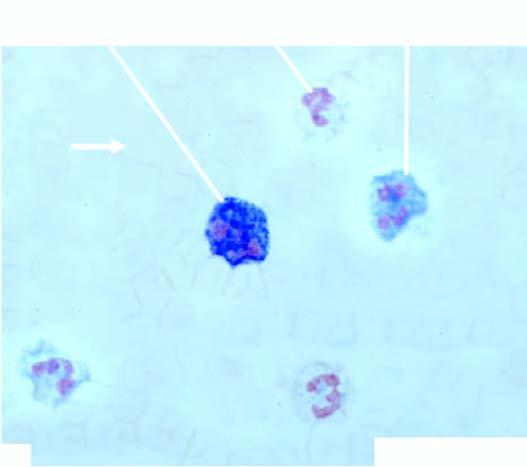what is higher as demonstrated by this cytochemical stain?
Answer the question using a single word or phrase. Neutrophil (or leucocyte) alkaline phosphatase (nap or lap) activity 